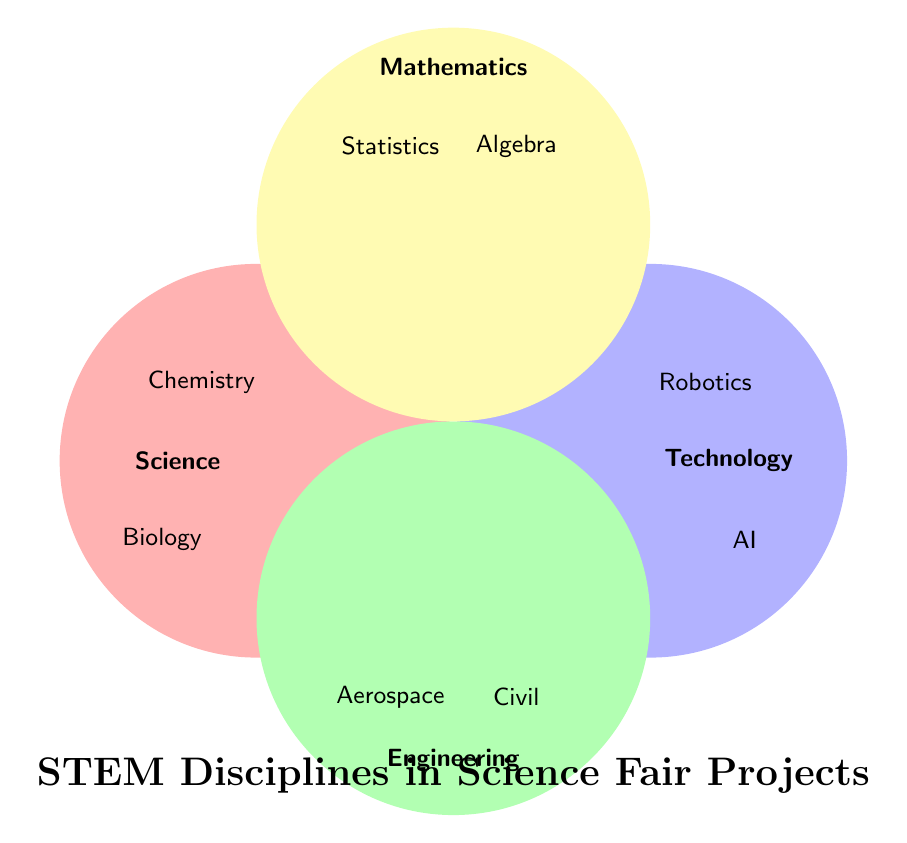What are the four main categories in the figure? The four main categories are represented by circles labeled with text. The categories are Science, Technology, Engineering, and Mathematics.
Answer: Science, Technology, Engineering, Mathematics Which category includes Robotics? Look for the label "Robotics" within one of the circles. Robotics is located in the circle labeled Technology.
Answer: Technology How many disciplines are listed under Mathematics? Count the number of listed items within the circle labeled Mathematics. There are two items: Statistics and Algebra.
Answer: 2 Which category includes the fewest disciplines? By counting the disciplines inside each circle: Technology and Mathematics have two each, while Science and Engineering have more.
Answer: Technology or Mathematics Are there any disciplines shared between Science and Engineering? Look for any overlapping areas between the Science and Engineering circles. There are no overlapping areas between these two circles.
Answer: No Which categories include disciplines that involve programming? Identify disciplines related to programming and find their categories. "Computer Programming" is under Technology, "Artificial Intelligence" is under Technology as well.
Answer: Technology Which category includes Civil Engineering? Find the label "Civil Engineering" and identify its circle. Civil Engineering is in the circle labeled Engineering.
Answer: Engineering Are there any disciplines related to environmental studies in the figure? Look for disciplines associated with environmental studies. "Ecology" in Science and "Environmental Engineering" in Engineering fit this criterion.
Answer: Yes What discipline is associated with both Science and Mathematics? Check for any areas where Science and Mathematics overlap. There is no overlap present in the figure.
Answer: None 